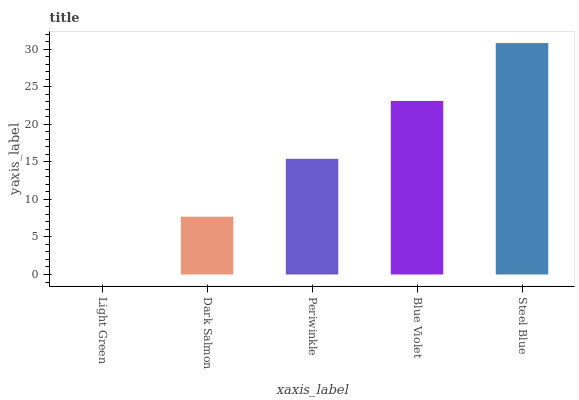Is Light Green the minimum?
Answer yes or no. Yes. Is Steel Blue the maximum?
Answer yes or no. Yes. Is Dark Salmon the minimum?
Answer yes or no. No. Is Dark Salmon the maximum?
Answer yes or no. No. Is Dark Salmon greater than Light Green?
Answer yes or no. Yes. Is Light Green less than Dark Salmon?
Answer yes or no. Yes. Is Light Green greater than Dark Salmon?
Answer yes or no. No. Is Dark Salmon less than Light Green?
Answer yes or no. No. Is Periwinkle the high median?
Answer yes or no. Yes. Is Periwinkle the low median?
Answer yes or no. Yes. Is Dark Salmon the high median?
Answer yes or no. No. Is Dark Salmon the low median?
Answer yes or no. No. 